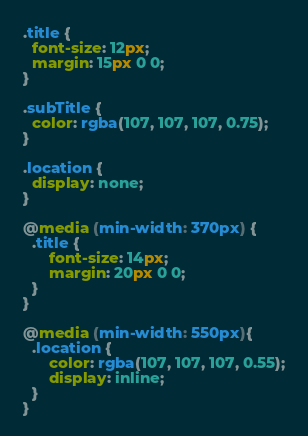<code> <loc_0><loc_0><loc_500><loc_500><_CSS_>.title {
  font-size: 12px;
  margin: 15px 0 0;
}

.subTitle {
  color: rgba(107, 107, 107, 0.75);
}

.location {
  display: none;
}

@media (min-width: 370px) {
  .title {
      font-size: 14px;
      margin: 20px 0 0;
  }
}

@media (min-width: 550px){
  .location {
      color: rgba(107, 107, 107, 0.55);
      display: inline;
  }
}
</code> 